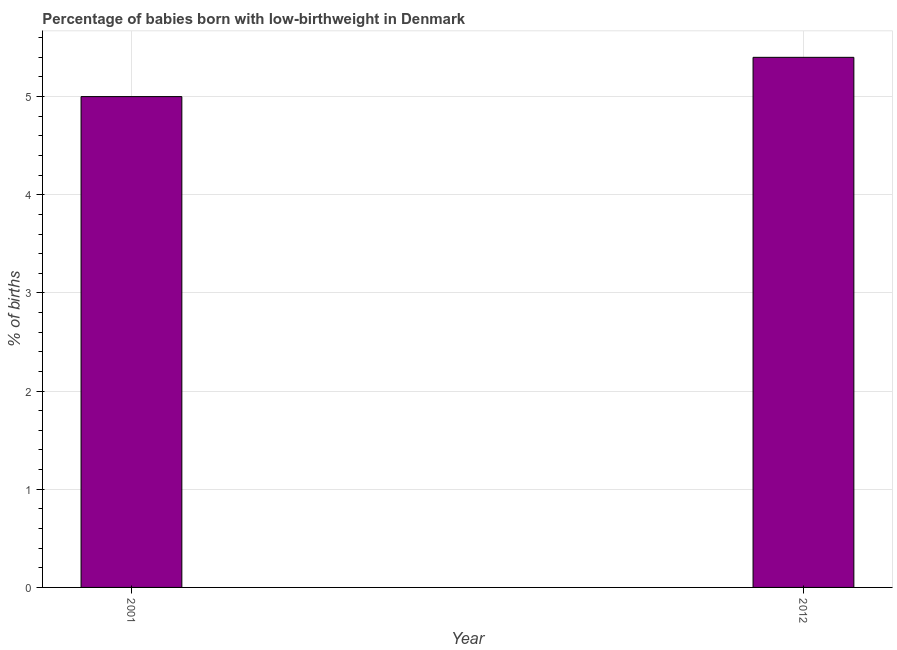What is the title of the graph?
Offer a terse response. Percentage of babies born with low-birthweight in Denmark. What is the label or title of the Y-axis?
Make the answer very short. % of births. What is the percentage of babies who were born with low-birthweight in 2012?
Your answer should be compact. 5.4. Across all years, what is the maximum percentage of babies who were born with low-birthweight?
Make the answer very short. 5.4. In which year was the percentage of babies who were born with low-birthweight maximum?
Your response must be concise. 2012. What is the sum of the percentage of babies who were born with low-birthweight?
Your answer should be compact. 10.4. What is the median percentage of babies who were born with low-birthweight?
Keep it short and to the point. 5.2. Do a majority of the years between 2001 and 2012 (inclusive) have percentage of babies who were born with low-birthweight greater than 1 %?
Your answer should be compact. Yes. What is the ratio of the percentage of babies who were born with low-birthweight in 2001 to that in 2012?
Your response must be concise. 0.93. Is the percentage of babies who were born with low-birthweight in 2001 less than that in 2012?
Offer a terse response. Yes. In how many years, is the percentage of babies who were born with low-birthweight greater than the average percentage of babies who were born with low-birthweight taken over all years?
Give a very brief answer. 1. Are all the bars in the graph horizontal?
Make the answer very short. No. Are the values on the major ticks of Y-axis written in scientific E-notation?
Offer a terse response. No. What is the % of births of 2012?
Ensure brevity in your answer.  5.4. What is the difference between the % of births in 2001 and 2012?
Provide a short and direct response. -0.4. What is the ratio of the % of births in 2001 to that in 2012?
Ensure brevity in your answer.  0.93. 